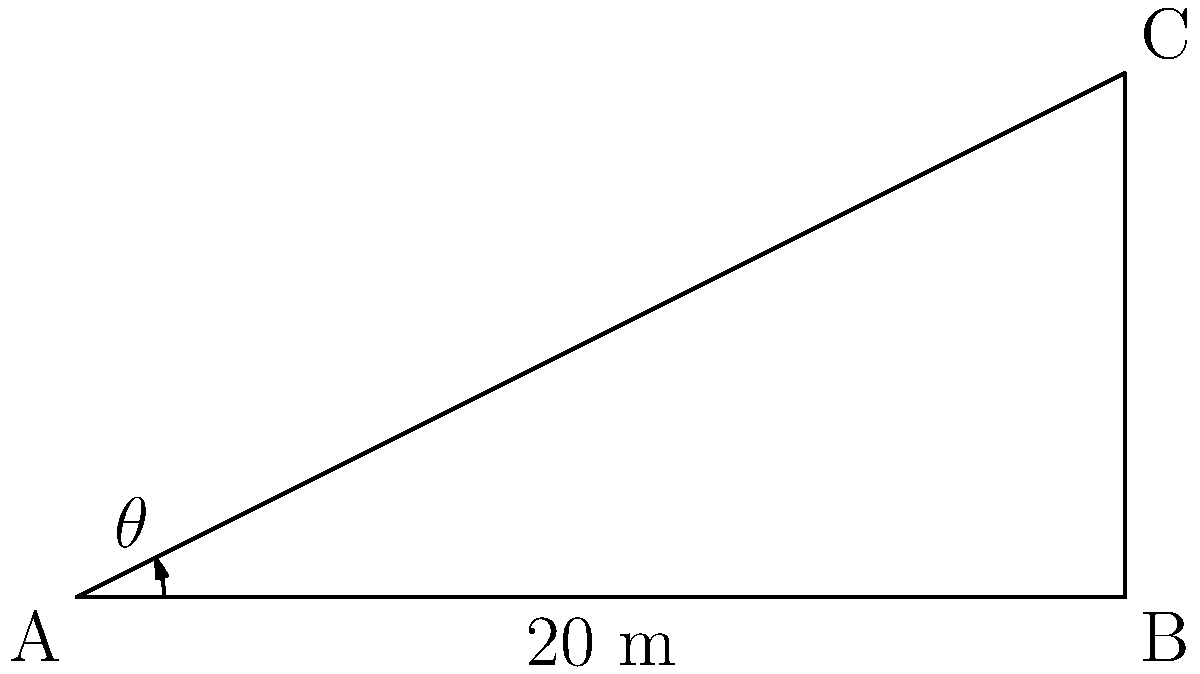You're considering a summer job as a window washer for tall buildings in Grandview. To prepare for the job, you need to calculate angles of elevation. If you're standing 20 meters away from a building and the top of the building is 10 meters high, what is the angle of elevation (θ) to the top of the building? Round your answer to the nearest degree. Let's approach this step-by-step:

1) We can treat this as a right-angled triangle problem. The building forms the vertical side (opposite to the angle θ), and your distance from the building forms the horizontal side (adjacent to the angle θ).

2) We know:
   - The adjacent side (distance from the building) = 20 meters
   - The opposite side (height of the building) = 10 meters

3) To find the angle, we can use the tangent function:

   $\tan(\theta) = \frac{\text{opposite}}{\text{adjacent}} = \frac{\text{height}}{\text{distance}}$

4) Plugging in our values:

   $\tan(\theta) = \frac{10}{20} = 0.5$

5) To find θ, we need to use the inverse tangent (arctan or tan^(-1)):

   $\theta = \tan^{-1}(0.5)$

6) Using a calculator or math library:

   $\theta \approx 26.57°$

7) Rounding to the nearest degree:

   $\theta \approx 27°$
Answer: 27° 